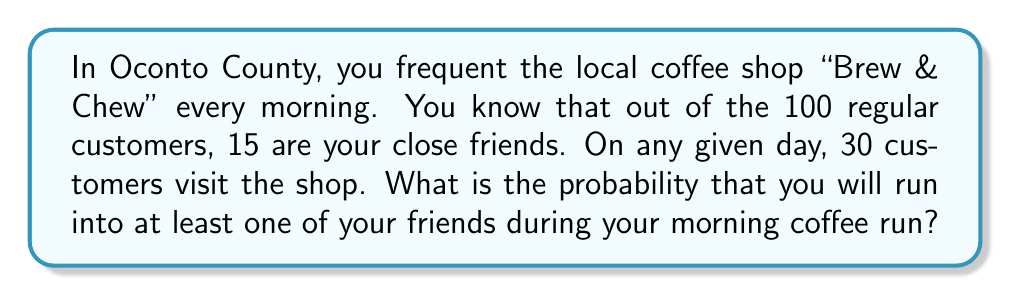Can you solve this math problem? Let's approach this step-by-step using probability theory:

1) First, let's calculate the probability of not running into any friends.

2) The probability of selecting a non-friend customer is:

   $\frac{100 - 15}{100} = \frac{85}{100}$

3) We need to select 30 customers, all of whom are not friends. This can be represented as:

   $P(\text{no friends}) = (\frac{85}{100})(\frac{84}{99})(\frac{83}{98})...(\frac{56}{71})$

4) This is equivalent to:

   $P(\text{no friends}) = \frac{85 \cdot 84 \cdot 83 \cdot ... \cdot 56}{100 \cdot 99 \cdot 98 \cdot ... \cdot 71}$

5) This can be written using combination notation:

   $P(\text{no friends}) = \frac{\binom{85}{30}}{\binom{100}{30}}$

6) Calculate this value:

   $P(\text{no friends}) \approx 0.0139$

7) Therefore, the probability of running into at least one friend is:

   $P(\text{at least one friend}) = 1 - P(\text{no friends}) = 1 - 0.0139 = 0.9861$
Answer: The probability of running into at least one friend at the local coffee shop is approximately 0.9861 or 98.61%. 